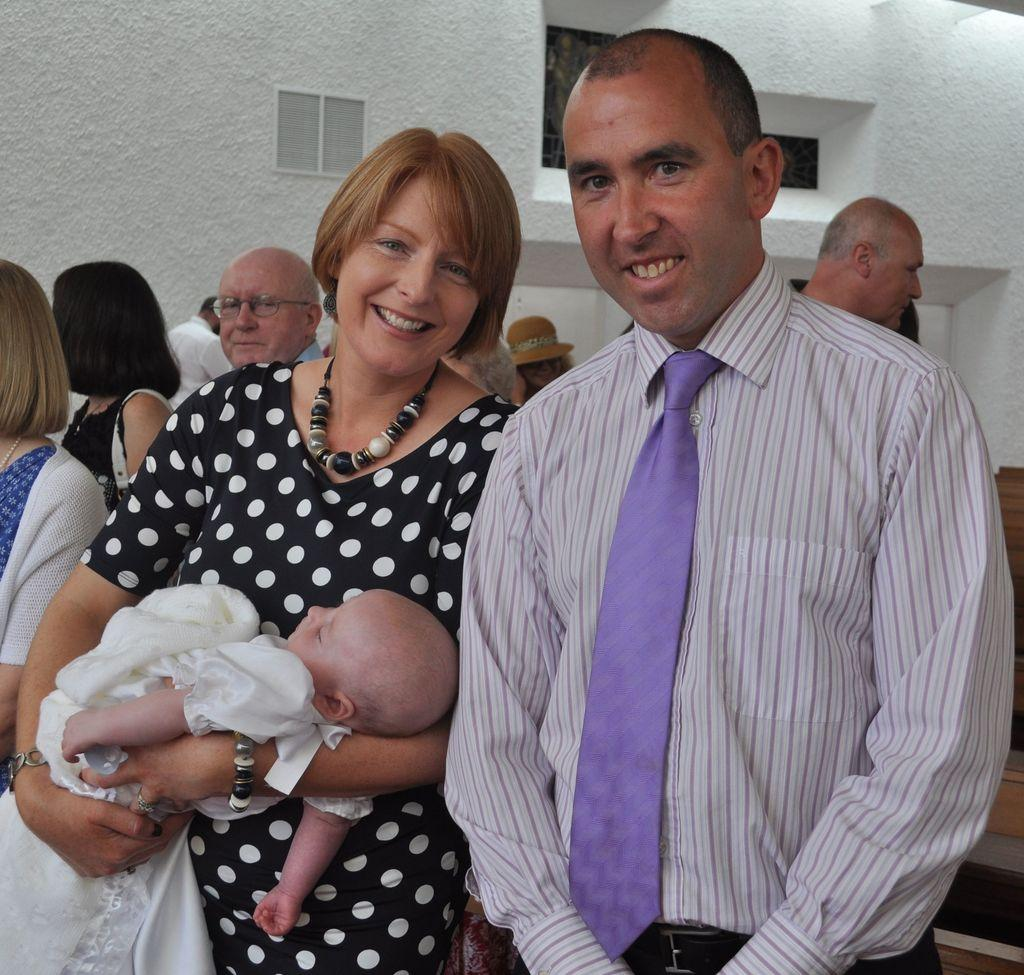How many people are in the image? There are people in the image, but the exact number is not specified. What is one person doing with the baby in the image? One person is carrying a baby in the image. What can be seen in the background of the image? There is a building in the background of the image. What type of crime is being committed in the image? There is no indication of any crime being committed in the image. What is the baby eating for lunch in the image? There is no information about the baby eating lunch in the image. 